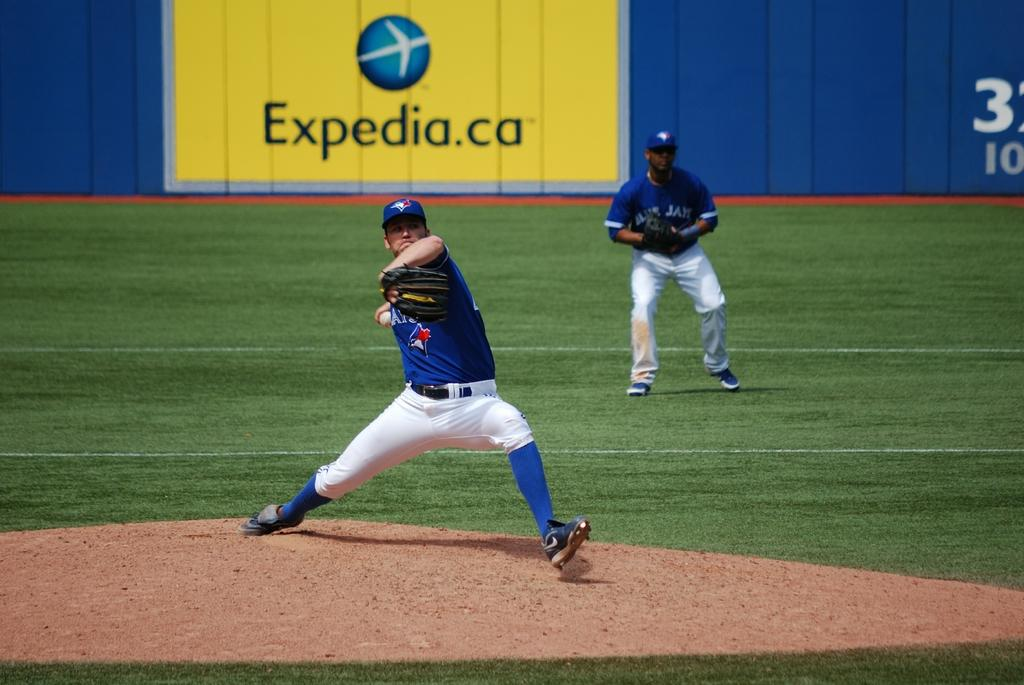<image>
Describe the image concisely. Players for the Blue Jays in front of an Expedia ad. 